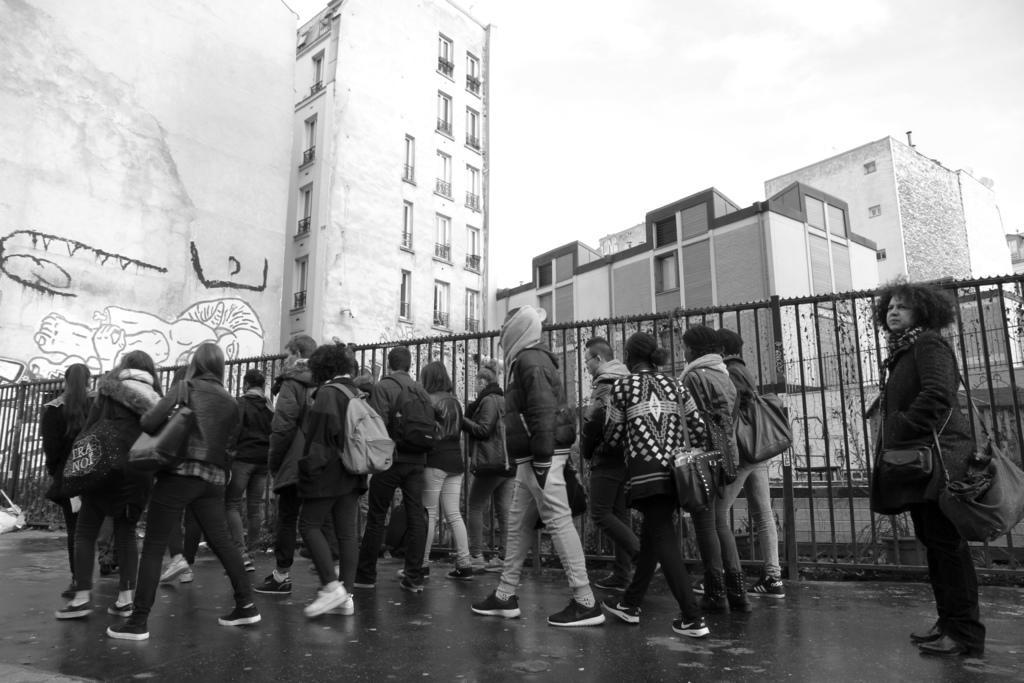Could you give a brief overview of what you see in this image? In this image I can see the black and white picture in which I can see few persons are standing on the ground, the metal railing, few buildings and a huge banner with some painting on it. In the background I can see the sky. 